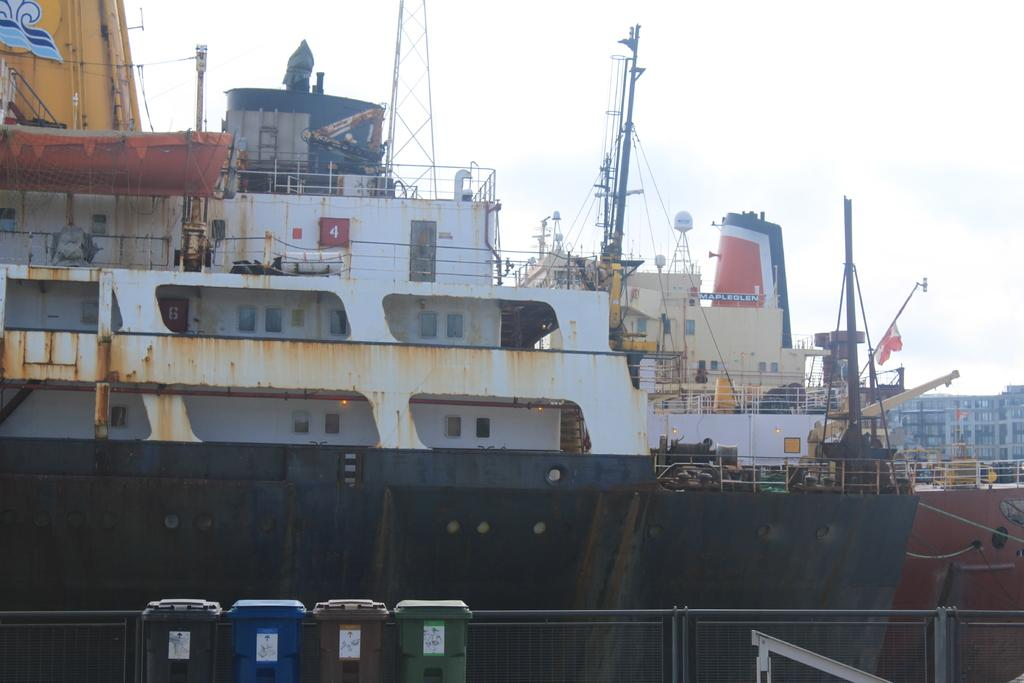<image>
Write a terse but informative summary of the picture. A large ship has a sign that says Mapleglen on it. 